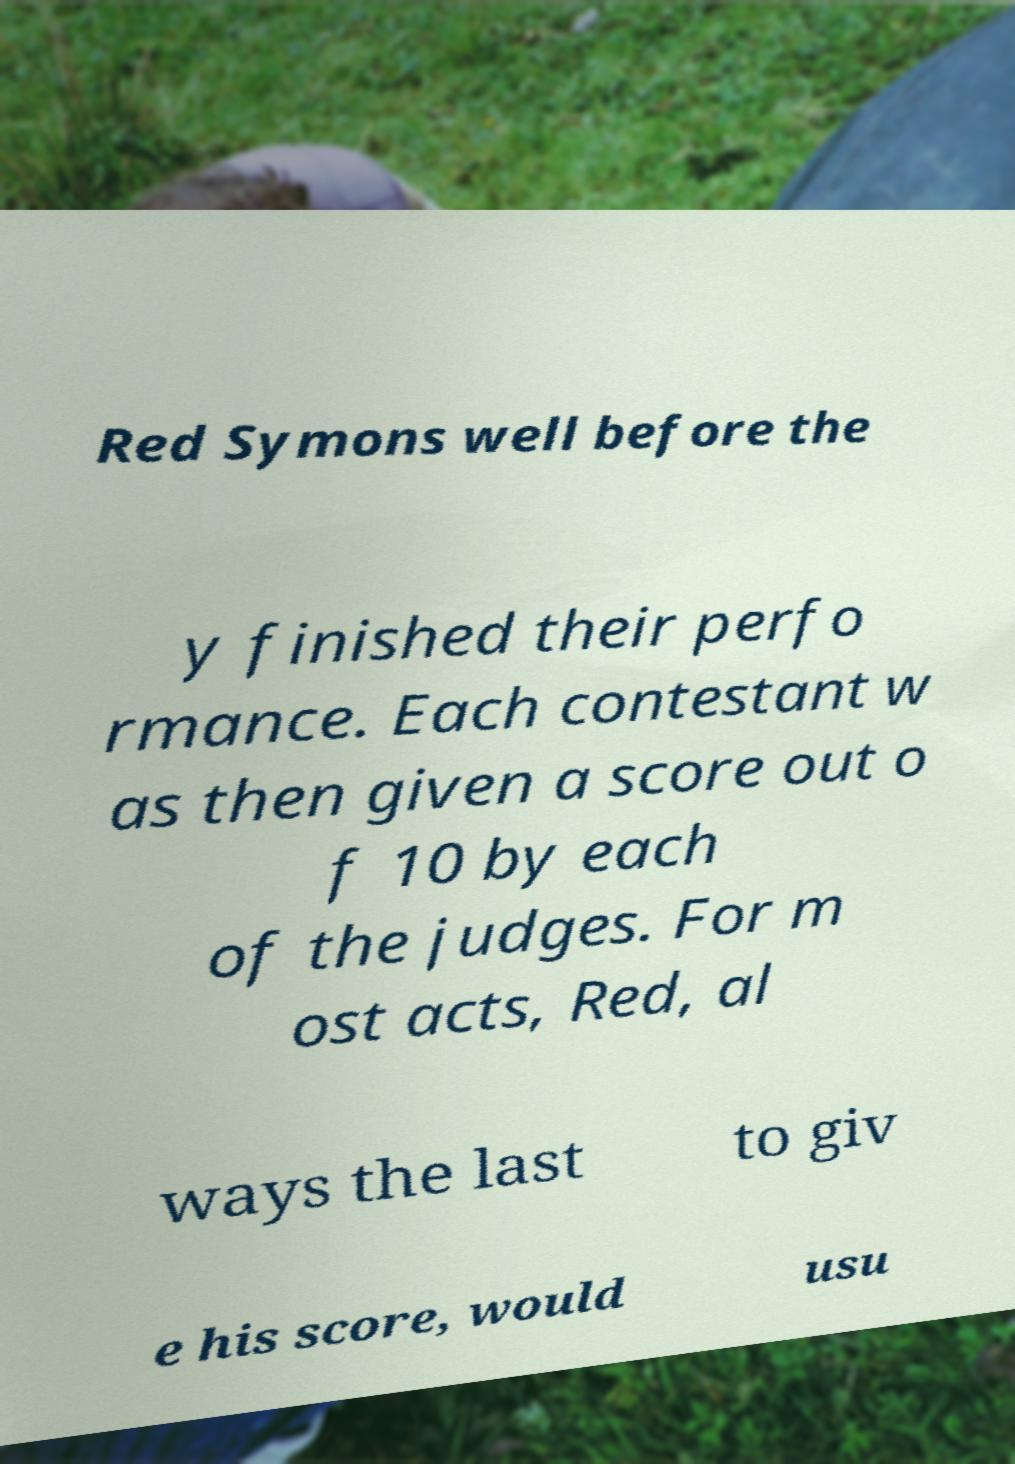Could you assist in decoding the text presented in this image and type it out clearly? Red Symons well before the y finished their perfo rmance. Each contestant w as then given a score out o f 10 by each of the judges. For m ost acts, Red, al ways the last to giv e his score, would usu 